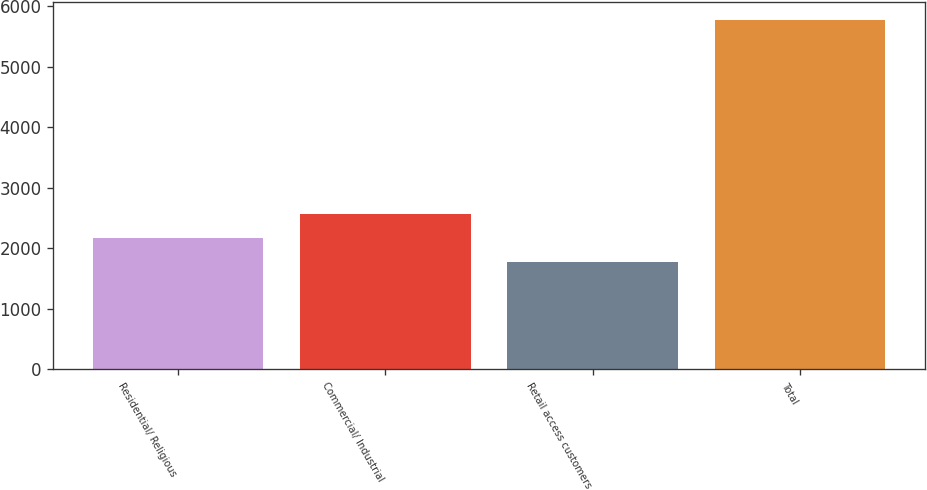Convert chart to OTSL. <chart><loc_0><loc_0><loc_500><loc_500><bar_chart><fcel>Residential/ Religious<fcel>Commercial/ Industrial<fcel>Retail access customers<fcel>Total<nl><fcel>2166.1<fcel>2567.2<fcel>1765<fcel>5776<nl></chart> 